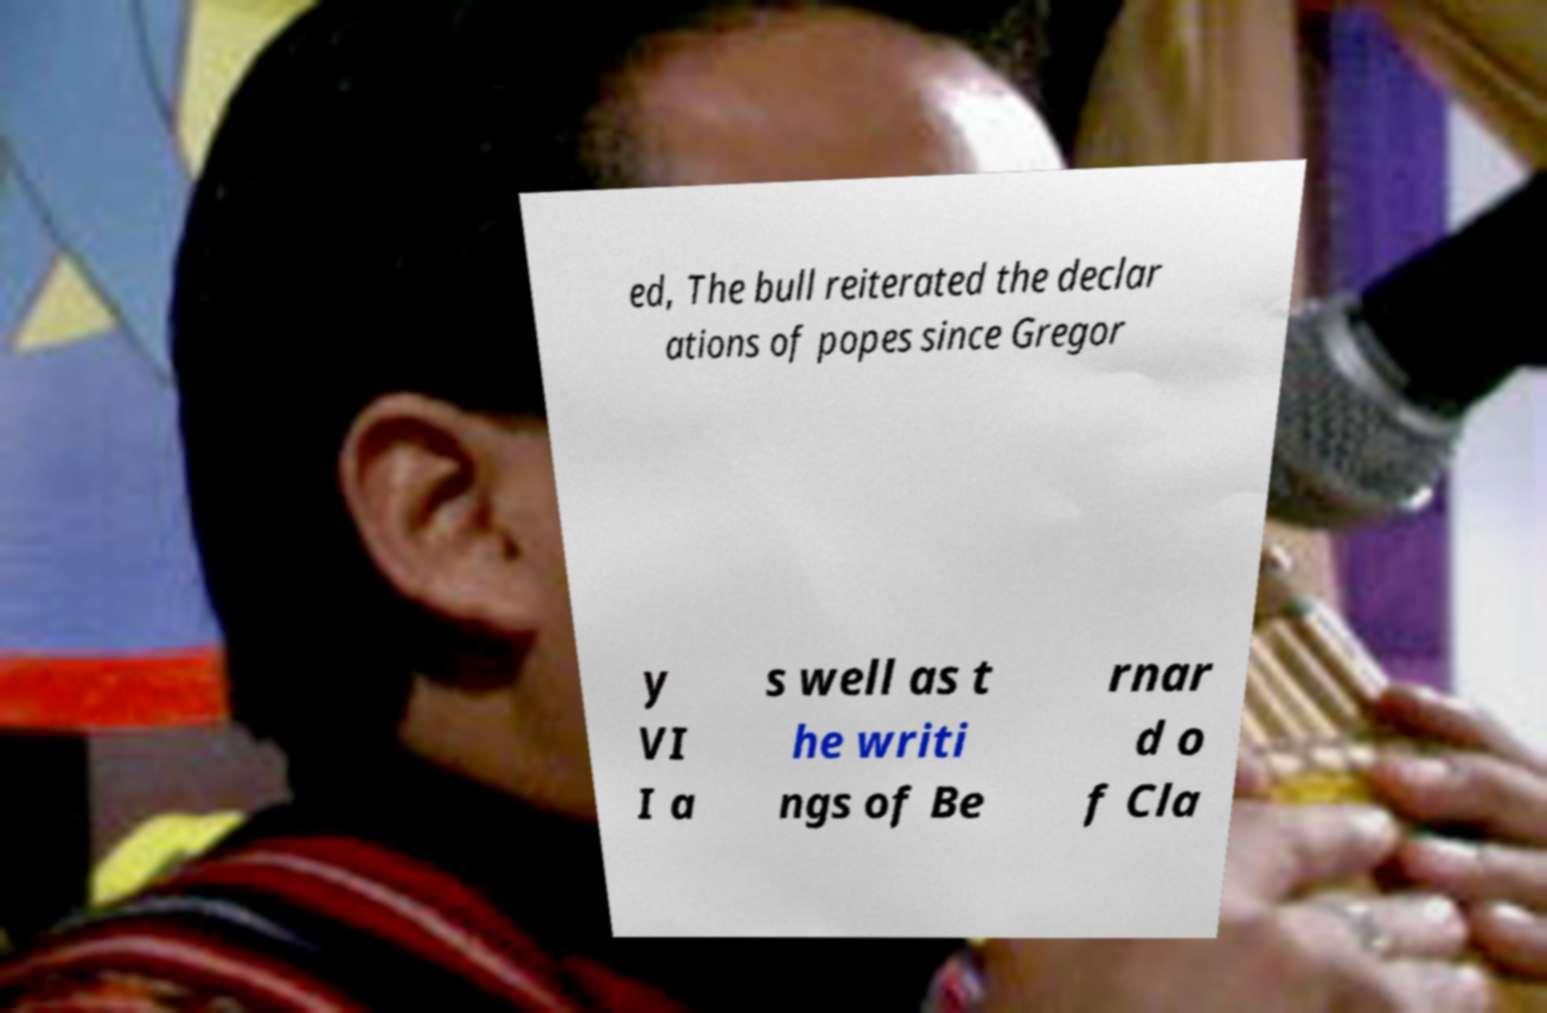Could you extract and type out the text from this image? ed, The bull reiterated the declar ations of popes since Gregor y VI I a s well as t he writi ngs of Be rnar d o f Cla 